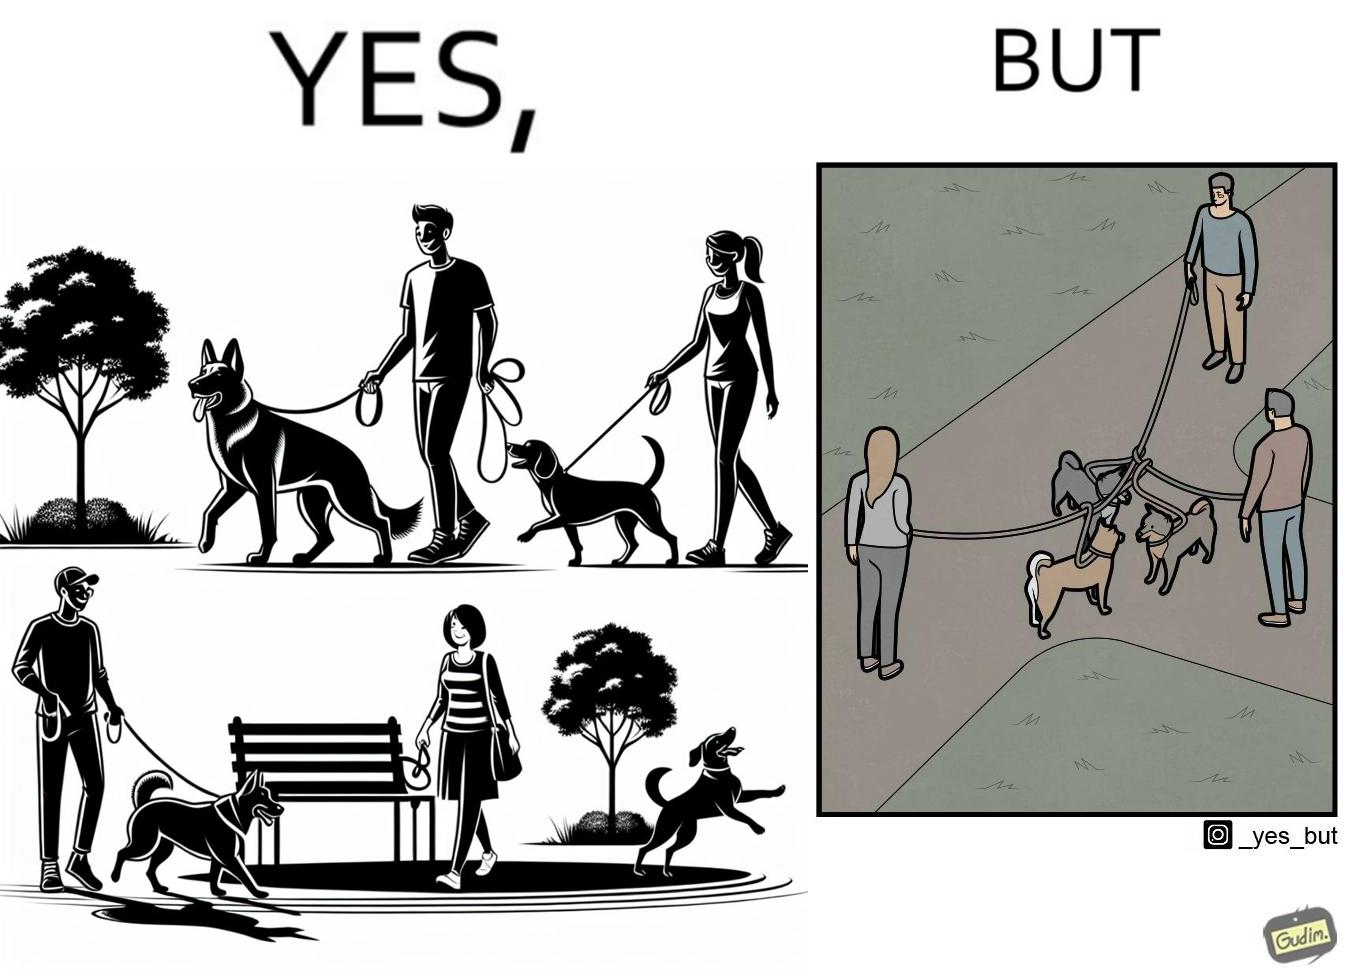Describe the contrast between the left and right parts of this image. In the left part of the image: three different dog owners with their dog walking in some park In the right part of the image: three different dog owners with their dog walking in some park with their dogs mingled 